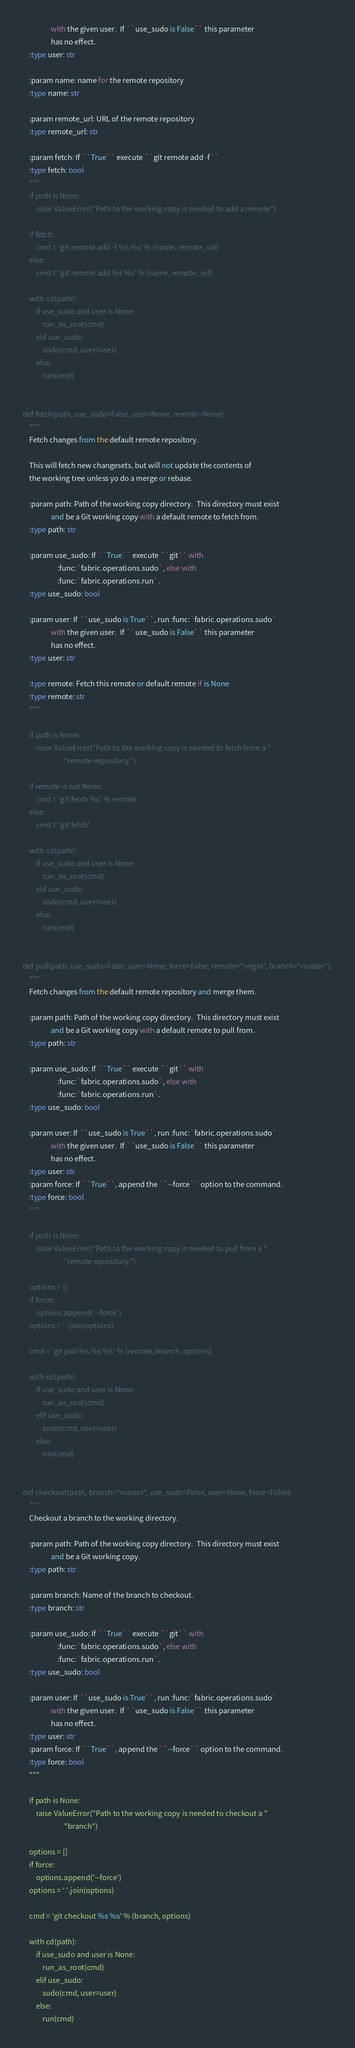<code> <loc_0><loc_0><loc_500><loc_500><_Python_>                 with the given user.  If ``use_sudo is False`` this parameter
                 has no effect.
    :type user: str

    :param name: name for the remote repository
    :type name: str

    :param remote_url: URL of the remote repository
    :type remote_url: str

    :param fetch: If ``True`` execute ``git remote add -f``
    :type fetch: bool
    """
    if path is None:
        raise ValueError("Path to the working copy is needed to add a remote")

    if fetch:
        cmd = 'git remote add -f %s %s' % (name, remote_url)
    else:
        cmd = 'git remote add %s %s' % (name, remote_url)

    with cd(path):
        if use_sudo and user is None:
            run_as_root(cmd)
        elif use_sudo:
            sudo(cmd, user=user)
        else:
            run(cmd)


def fetch(path, use_sudo=False, user=None, remote=None):
    """
    Fetch changes from the default remote repository.

    This will fetch new changesets, but will not update the contents of
    the working tree unless yo do a merge or rebase.

    :param path: Path of the working copy directory.  This directory must exist
                 and be a Git working copy with a default remote to fetch from.
    :type path: str

    :param use_sudo: If ``True`` execute ``git`` with
                     :func:`fabric.operations.sudo`, else with
                     :func:`fabric.operations.run`.
    :type use_sudo: bool

    :param user: If ``use_sudo is True``, run :func:`fabric.operations.sudo`
                 with the given user.  If ``use_sudo is False`` this parameter
                 has no effect.
    :type user: str

    :type remote: Fetch this remote or default remote if is None
    :type remote: str
    """

    if path is None:
        raise ValueError("Path to the working copy is needed to fetch from a "
                         "remote repository.")

    if remote is not None:
        cmd = 'git fetch %s' % remote
    else:
        cmd = 'git fetch'

    with cd(path):
        if use_sudo and user is None:
            run_as_root(cmd)
        elif use_sudo:
            sudo(cmd, user=user)
        else:
            run(cmd)


def pull(path, use_sudo=False, user=None, force=False, remote="origin", branch="master"):
    """
    Fetch changes from the default remote repository and merge them.

    :param path: Path of the working copy directory.  This directory must exist
                 and be a Git working copy with a default remote to pull from.
    :type path: str

    :param use_sudo: If ``True`` execute ``git`` with
                     :func:`fabric.operations.sudo`, else with
                     :func:`fabric.operations.run`.
    :type use_sudo: bool

    :param user: If ``use_sudo is True``, run :func:`fabric.operations.sudo`
                 with the given user.  If ``use_sudo is False`` this parameter
                 has no effect.
    :type user: str
    :param force: If ``True``, append the ``--force`` option to the command.
    :type force: bool
    """

    if path is None:
        raise ValueError("Path to the working copy is needed to pull from a "
                         "remote repository.")

    options = []
    if force:
        options.append('--force')
    options = ' '.join(options)

    cmd = 'git pull %s %s %s' % (remote, branch, options)

    with cd(path):
        if use_sudo and user is None:
            run_as_root(cmd)
        elif use_sudo:
            sudo(cmd, user=user)
        else:
            run(cmd)


def checkout(path, branch="master", use_sudo=False, user=None, force=False):
    """
    Checkout a branch to the working directory.

    :param path: Path of the working copy directory.  This directory must exist
                 and be a Git working copy.
    :type path: str

    :param branch: Name of the branch to checkout.
    :type branch: str

    :param use_sudo: If ``True`` execute ``git`` with
                     :func:`fabric.operations.sudo`, else with
                     :func:`fabric.operations.run`.
    :type use_sudo: bool

    :param user: If ``use_sudo is True``, run :func:`fabric.operations.sudo`
                 with the given user.  If ``use_sudo is False`` this parameter
                 has no effect.
    :type user: str
    :param force: If ``True``, append the ``--force`` option to the command.
    :type force: bool
    """

    if path is None:
        raise ValueError("Path to the working copy is needed to checkout a "
                         "branch")

    options = []
    if force:
        options.append('--force')
    options = ' '.join(options)

    cmd = 'git checkout %s %s' % (branch, options)

    with cd(path):
        if use_sudo and user is None:
            run_as_root(cmd)
        elif use_sudo:
            sudo(cmd, user=user)
        else:
            run(cmd)
</code> 